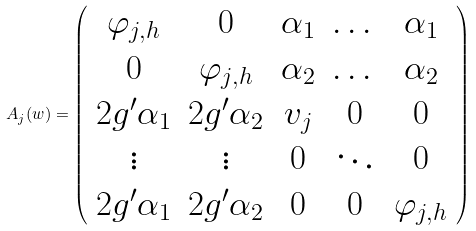<formula> <loc_0><loc_0><loc_500><loc_500>A _ { j } ( w ) = \left ( \begin{array} { c c c c c } \varphi _ { j , h } & 0 & \alpha _ { 1 } & \dots & \alpha _ { 1 } \\ 0 & \varphi _ { j , h } & \alpha _ { 2 } & \dots & \alpha _ { 2 } \\ 2 g ^ { \prime } \alpha _ { 1 } & 2 g ^ { \prime } \alpha _ { 2 } & v _ { j } & 0 & 0 \\ \vdots & \vdots & 0 & \ddots & 0 \\ 2 g ^ { \prime } \alpha _ { 1 } & 2 g ^ { \prime } \alpha _ { 2 } & 0 & 0 & \varphi _ { j , h } \end{array} \right )</formula> 